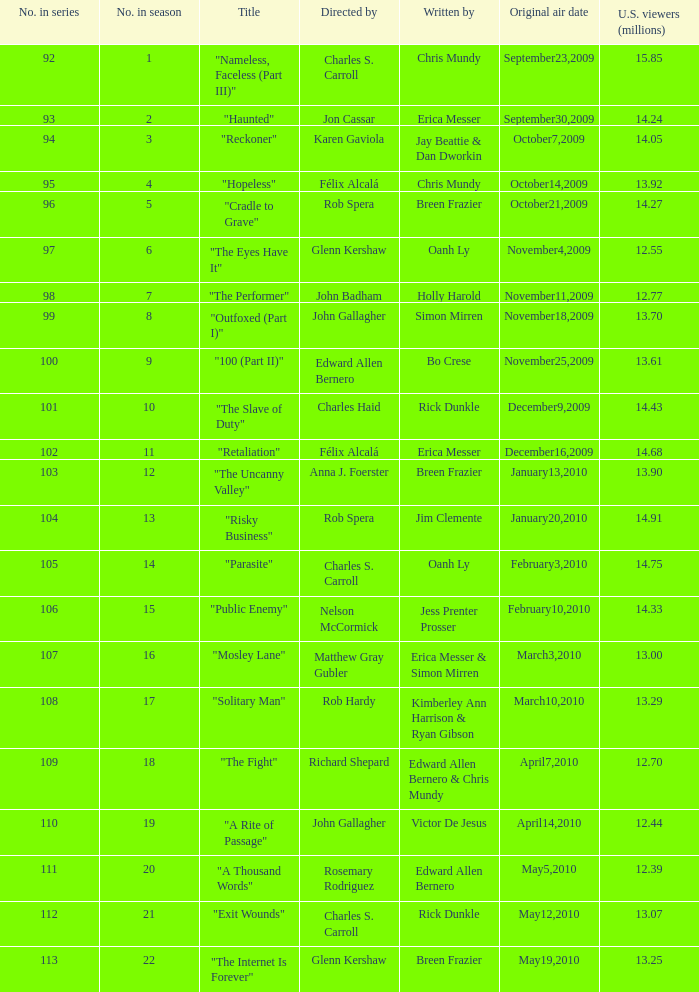Which number(s) in the sequence were authored by bo crese? 100.0. 